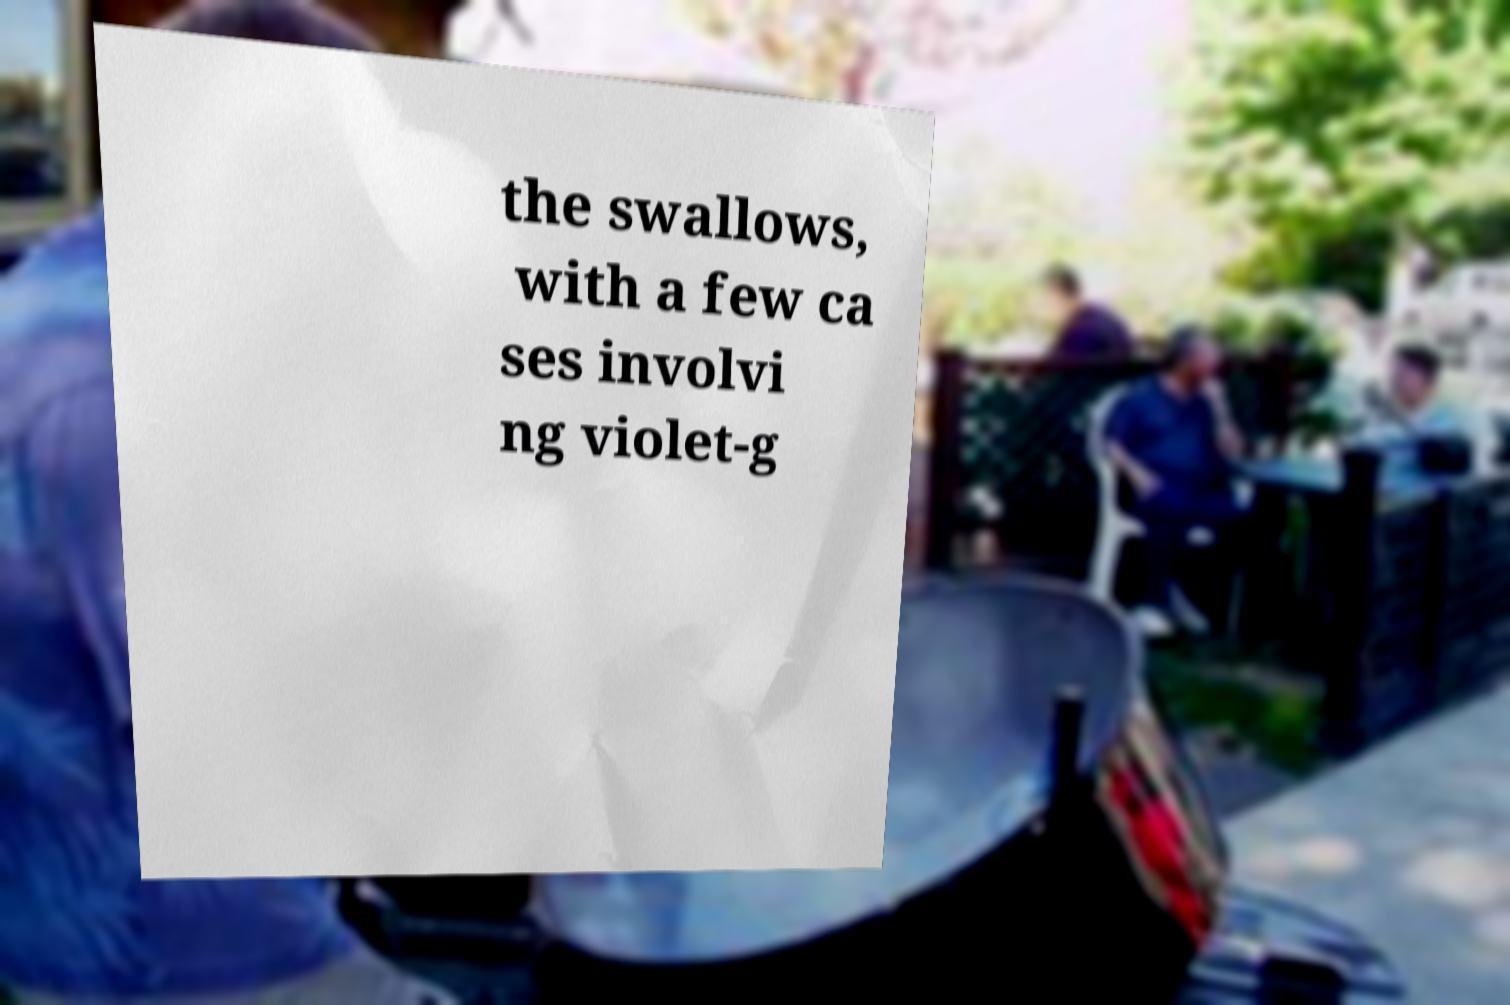Could you assist in decoding the text presented in this image and type it out clearly? the swallows, with a few ca ses involvi ng violet-g 